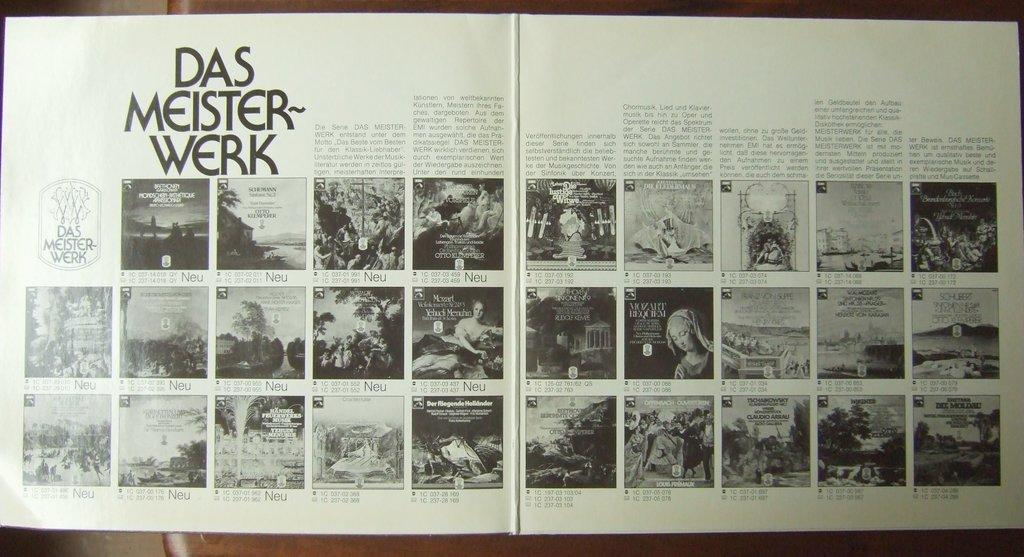Provide a one-sentence caption for the provided image. A catalogue is open to a section titled Das Meister-werk. 